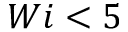Convert formula to latex. <formula><loc_0><loc_0><loc_500><loc_500>W i < 5</formula> 